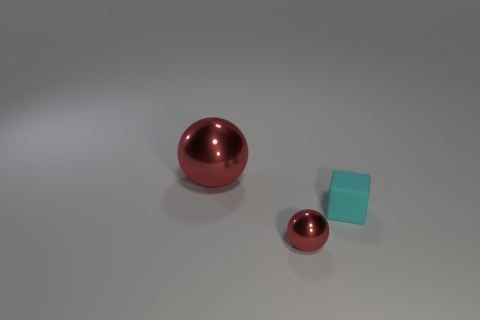How many other things are the same shape as the big red thing?
Your answer should be very brief. 1. Is the tiny object that is behind the tiny red metal thing made of the same material as the big red ball?
Ensure brevity in your answer.  No. Are there an equal number of small cyan rubber cubes behind the small cyan block and large red shiny balls that are to the left of the big red metal ball?
Give a very brief answer. Yes. There is a red metallic thing in front of the big metallic sphere; what size is it?
Provide a succinct answer. Small. Is there a thing that has the same material as the big ball?
Offer a very short reply. Yes. Does the tiny object left of the cyan matte block have the same color as the big shiny object?
Keep it short and to the point. Yes. Are there an equal number of metallic objects that are behind the cyan thing and small red objects?
Ensure brevity in your answer.  Yes. Is there a matte cube of the same color as the big metallic ball?
Offer a very short reply. No. What size is the red shiny thing behind the metallic ball that is in front of the large red object?
Provide a succinct answer. Large. What size is the object that is both in front of the large metal object and on the left side of the small cyan matte object?
Provide a short and direct response. Small. 